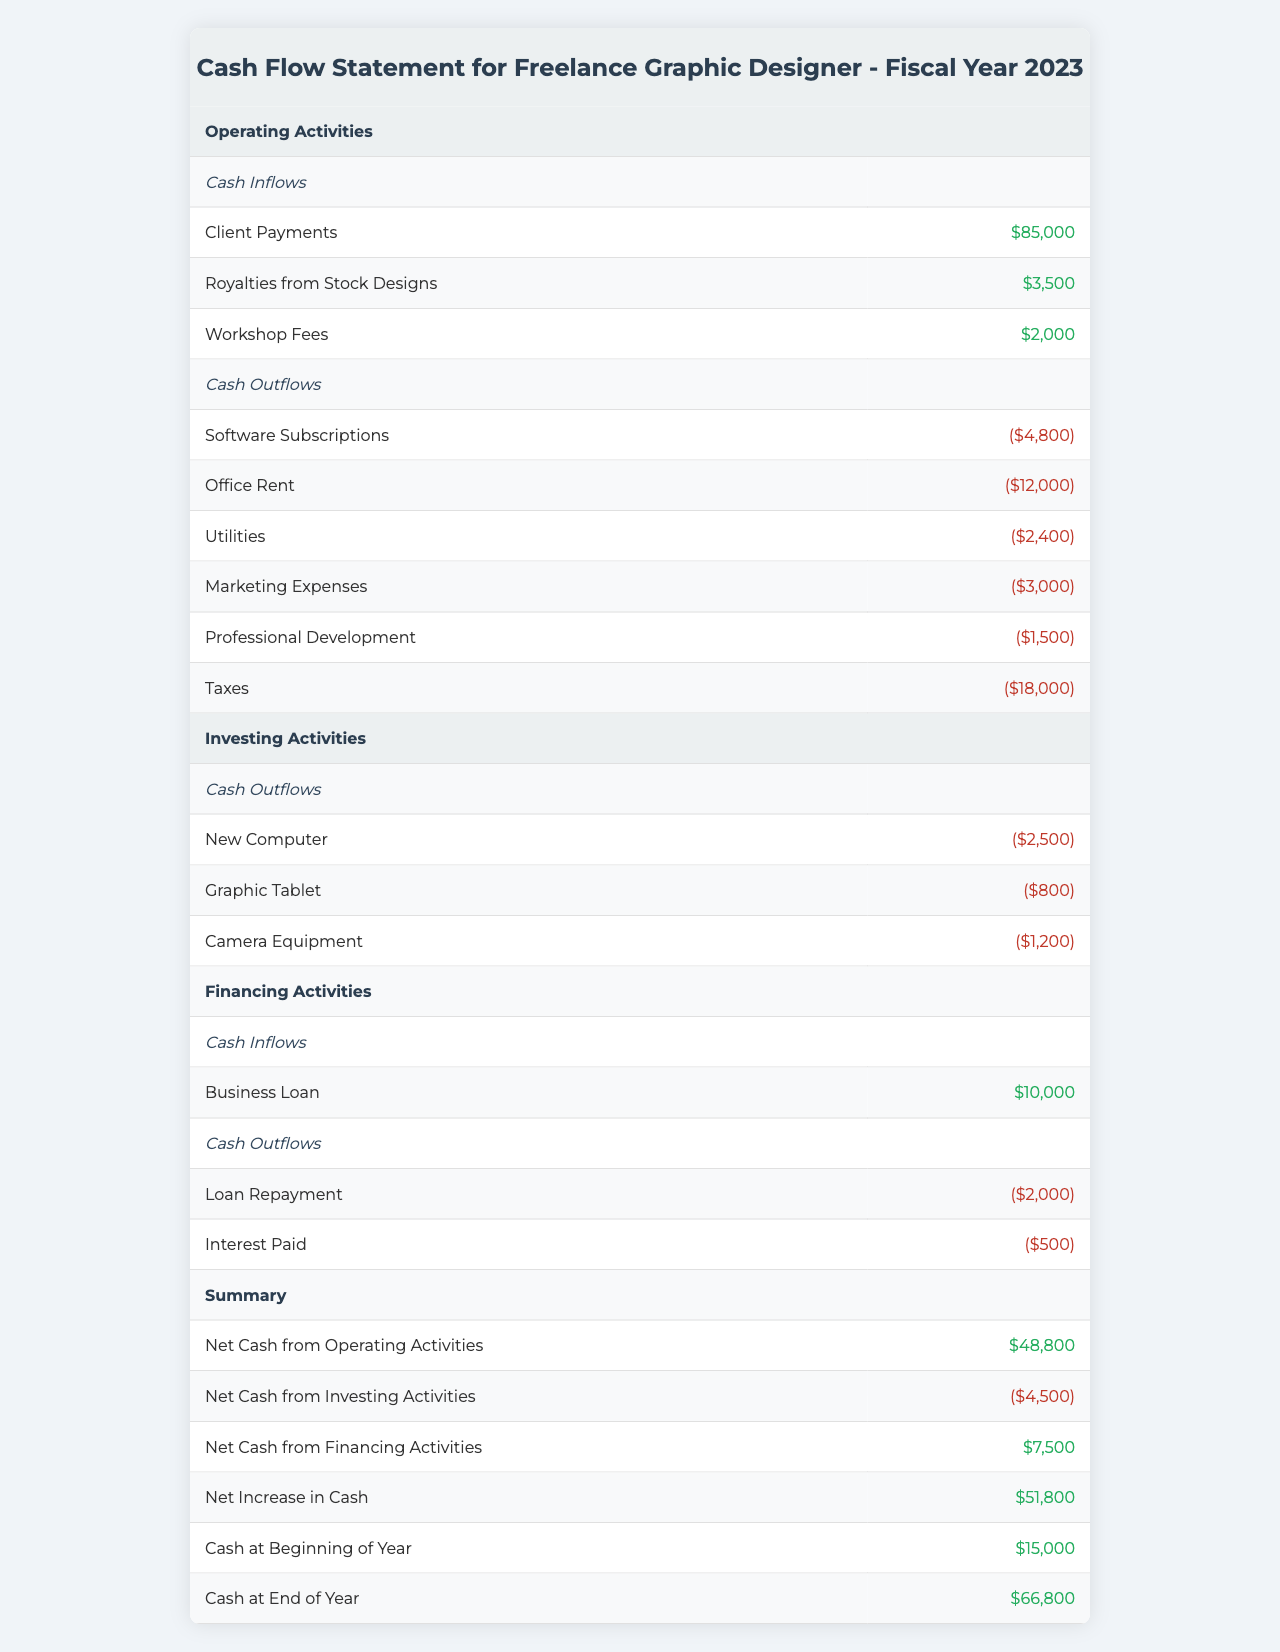What are the total cash inflows from operating activities? To find the total cash inflows from operating activities, add up the values for Client Payments ($85,000), Royalties from Stock Designs ($3,500), and Workshop Fees ($2,000). Thus, the total is $85,000 + $3,500 + $2,000 = $90,500.
Answer: $90,500 What is the total of cash outflows in investing activities? The cash outflows in investing activities include New Computer ($2,500), Graphic Tablet ($800), and Camera Equipment ($1,200). Adding these amounts gives $2,500 + $800 + $1,200 = $4,500.
Answer: $4,500 Did the business receive any cash inflows from financing activities? Yes, there was a cash inflow of $10,000 from a business loan under financing activities.
Answer: Yes What is the net cash position at the end of the year? To find the net cash position at the end of the year, we consider the Cash at Beginning of Year ($15,000) and the Net Increase in Cash ($51,800). Therefore, $15,000 + $51,800 = $66,800, which matches the Cash at End of Year value.
Answer: $66,800 How much cash was spent on marketing expenses? The cash spent on marketing expenses is directly shown as $3,000 in the cash outflows under operating activities.
Answer: $3,000 What is the net cash from financing activities? The net cash from financing activities can be calculated by subtracting total cash outflows from cash inflows. The inflow from Business Loan is $10,000, and the total outflows from Loan Repayment and Interest Paid are $2,000 + $500 = $2,500. Thus, $10,000 - $2,500 = $7,500.
Answer: $7,500 What are the total cash inflows in operating activities compared to total cash outflows in operating activities? The total cash inflows from operating activities are $90,500, while total cash outflows are $42,700 (calculated by summing all outflows). So, comparing cash inflows and outflows gives $90,500 vs $42,700.
Answer: $90,500 vs $42,700 How much did the graphic designer spend on professional development? The amount spent on professional development is listed as $1,500 under cash outflows in operating activities.
Answer: $1,500 What is the overall cash flow position when considering all activities? To find the overall cash flow position, calculate the total cash inflows and outflows from operating, investing, and financing activities, which results in adding net cash from each activity: $48,800 (operating) - $4,500 (investing) + $7,500 (financing) = $51,800, aligning with the Net Increase in Cash.
Answer: $51,800 Was the cash at the end of the year higher than at the beginning? Yes, the cash at the end of the year ($66,800) is higher than at the beginning ($15,000), indicating a positive cash flow over the year.
Answer: Yes 